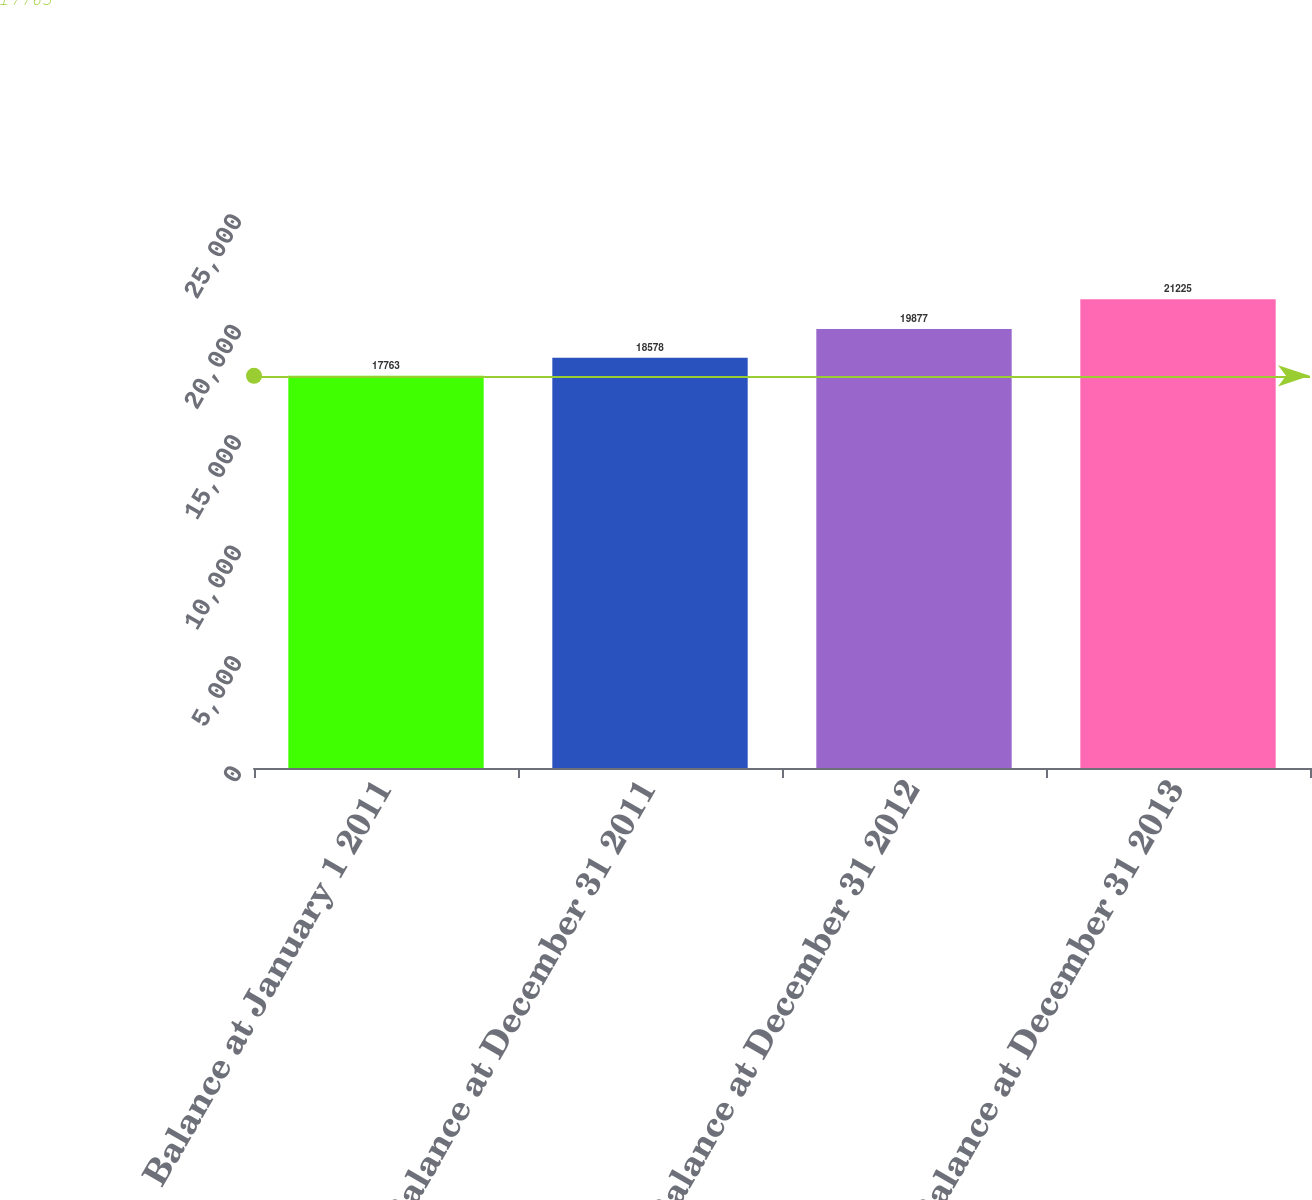Convert chart to OTSL. <chart><loc_0><loc_0><loc_500><loc_500><bar_chart><fcel>Balance at January 1 2011<fcel>Balance at December 31 2011<fcel>Balance at December 31 2012<fcel>Balance at December 31 2013<nl><fcel>17763<fcel>18578<fcel>19877<fcel>21225<nl></chart> 